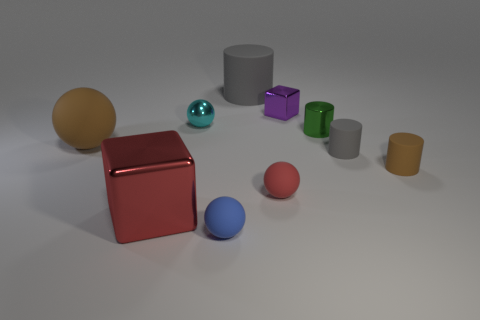What is the small ball behind the matte ball to the right of the large cylinder made of?
Your answer should be compact. Metal. Is the number of red rubber spheres in front of the tiny block less than the number of red objects that are in front of the small gray rubber cylinder?
Offer a very short reply. Yes. What number of yellow things are small cubes or cylinders?
Provide a succinct answer. 0. Are there an equal number of tiny purple things left of the tiny cyan thing and tiny green matte balls?
Provide a succinct answer. Yes. How many objects are either big objects or gray cylinders that are in front of the tiny cyan shiny thing?
Offer a very short reply. 4. Is the color of the metal cylinder the same as the big matte ball?
Your answer should be compact. No. Is there a small yellow cylinder that has the same material as the tiny brown cylinder?
Ensure brevity in your answer.  No. What color is the other thing that is the same shape as the large red thing?
Provide a succinct answer. Purple. Is the material of the big block the same as the red object that is to the right of the red metal block?
Your answer should be very brief. No. The tiny cyan shiny object that is on the left side of the small purple shiny object behind the large brown matte thing is what shape?
Offer a very short reply. Sphere. 